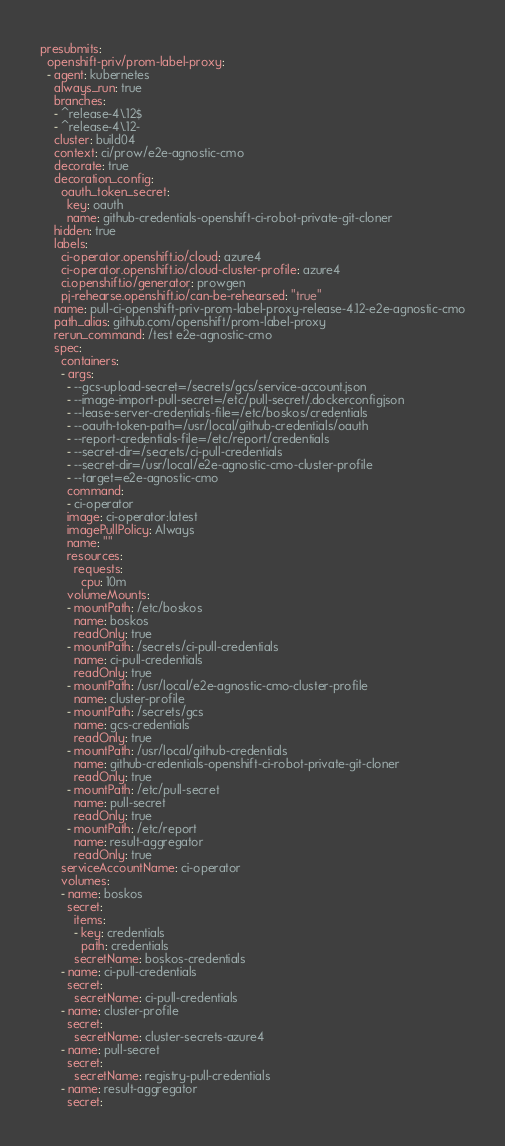<code> <loc_0><loc_0><loc_500><loc_500><_YAML_>presubmits:
  openshift-priv/prom-label-proxy:
  - agent: kubernetes
    always_run: true
    branches:
    - ^release-4\.12$
    - ^release-4\.12-
    cluster: build04
    context: ci/prow/e2e-agnostic-cmo
    decorate: true
    decoration_config:
      oauth_token_secret:
        key: oauth
        name: github-credentials-openshift-ci-robot-private-git-cloner
    hidden: true
    labels:
      ci-operator.openshift.io/cloud: azure4
      ci-operator.openshift.io/cloud-cluster-profile: azure4
      ci.openshift.io/generator: prowgen
      pj-rehearse.openshift.io/can-be-rehearsed: "true"
    name: pull-ci-openshift-priv-prom-label-proxy-release-4.12-e2e-agnostic-cmo
    path_alias: github.com/openshift/prom-label-proxy
    rerun_command: /test e2e-agnostic-cmo
    spec:
      containers:
      - args:
        - --gcs-upload-secret=/secrets/gcs/service-account.json
        - --image-import-pull-secret=/etc/pull-secret/.dockerconfigjson
        - --lease-server-credentials-file=/etc/boskos/credentials
        - --oauth-token-path=/usr/local/github-credentials/oauth
        - --report-credentials-file=/etc/report/credentials
        - --secret-dir=/secrets/ci-pull-credentials
        - --secret-dir=/usr/local/e2e-agnostic-cmo-cluster-profile
        - --target=e2e-agnostic-cmo
        command:
        - ci-operator
        image: ci-operator:latest
        imagePullPolicy: Always
        name: ""
        resources:
          requests:
            cpu: 10m
        volumeMounts:
        - mountPath: /etc/boskos
          name: boskos
          readOnly: true
        - mountPath: /secrets/ci-pull-credentials
          name: ci-pull-credentials
          readOnly: true
        - mountPath: /usr/local/e2e-agnostic-cmo-cluster-profile
          name: cluster-profile
        - mountPath: /secrets/gcs
          name: gcs-credentials
          readOnly: true
        - mountPath: /usr/local/github-credentials
          name: github-credentials-openshift-ci-robot-private-git-cloner
          readOnly: true
        - mountPath: /etc/pull-secret
          name: pull-secret
          readOnly: true
        - mountPath: /etc/report
          name: result-aggregator
          readOnly: true
      serviceAccountName: ci-operator
      volumes:
      - name: boskos
        secret:
          items:
          - key: credentials
            path: credentials
          secretName: boskos-credentials
      - name: ci-pull-credentials
        secret:
          secretName: ci-pull-credentials
      - name: cluster-profile
        secret:
          secretName: cluster-secrets-azure4
      - name: pull-secret
        secret:
          secretName: registry-pull-credentials
      - name: result-aggregator
        secret:</code> 